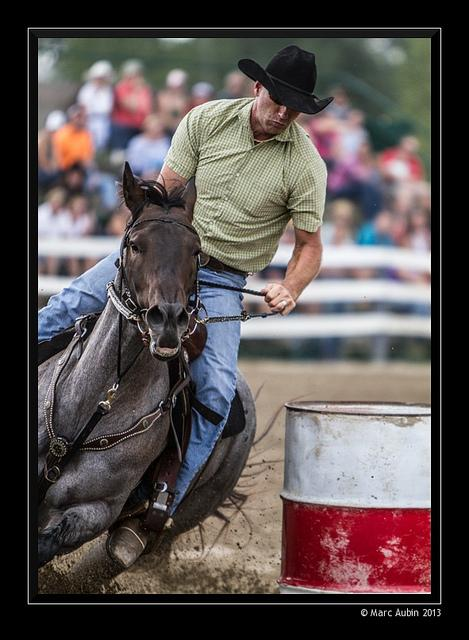What type activity does the man here take part in? Please explain your reasoning. barrel racing. A man is in an arena with a cowboy hat and is on a horse. bull riders wear cowboy hats and ride horses. 